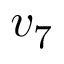<formula> <loc_0><loc_0><loc_500><loc_500>v _ { 7 }</formula> 